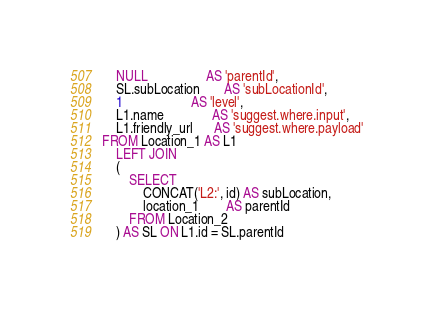Convert code to text. <code><loc_0><loc_0><loc_500><loc_500><_SQL_>    NULL                 AS 'parentId',
    SL.subLocation       AS 'subLocationId',
    1                    AS 'level',
    L1.name              AS 'suggest.where.input',
    L1.friendly_url      AS 'suggest.where.payload'
FROM Location_1 AS L1
    LEFT JOIN
    (
        SELECT
            CONCAT('L2:', id) AS subLocation,
            location_1        AS parentId
        FROM Location_2
    ) AS SL ON L1.id = SL.parentId
</code> 